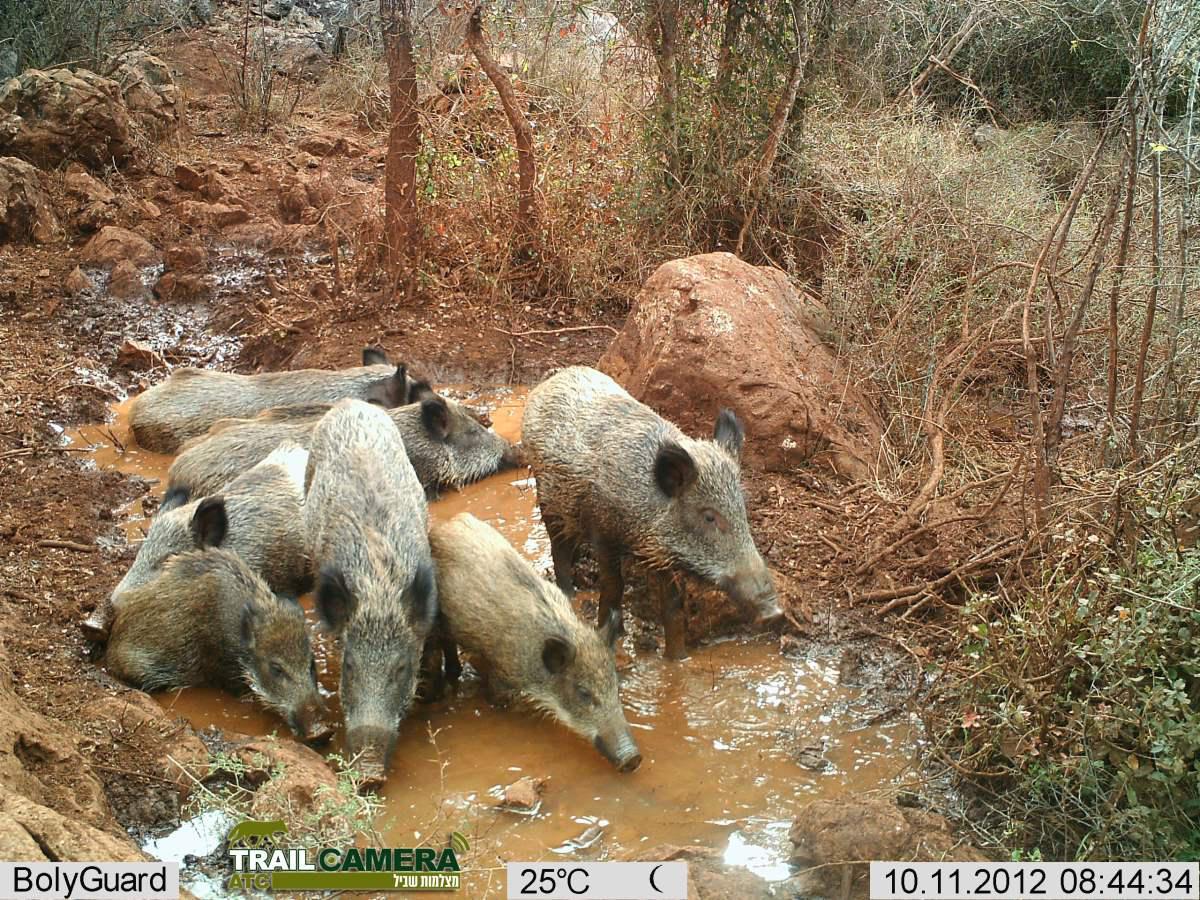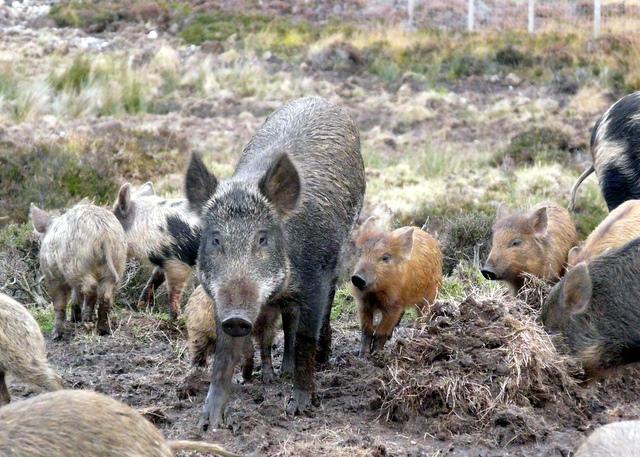The first image is the image on the left, the second image is the image on the right. Examine the images to the left and right. Is the description "At least one image is not of pigs." accurate? Answer yes or no. No. 